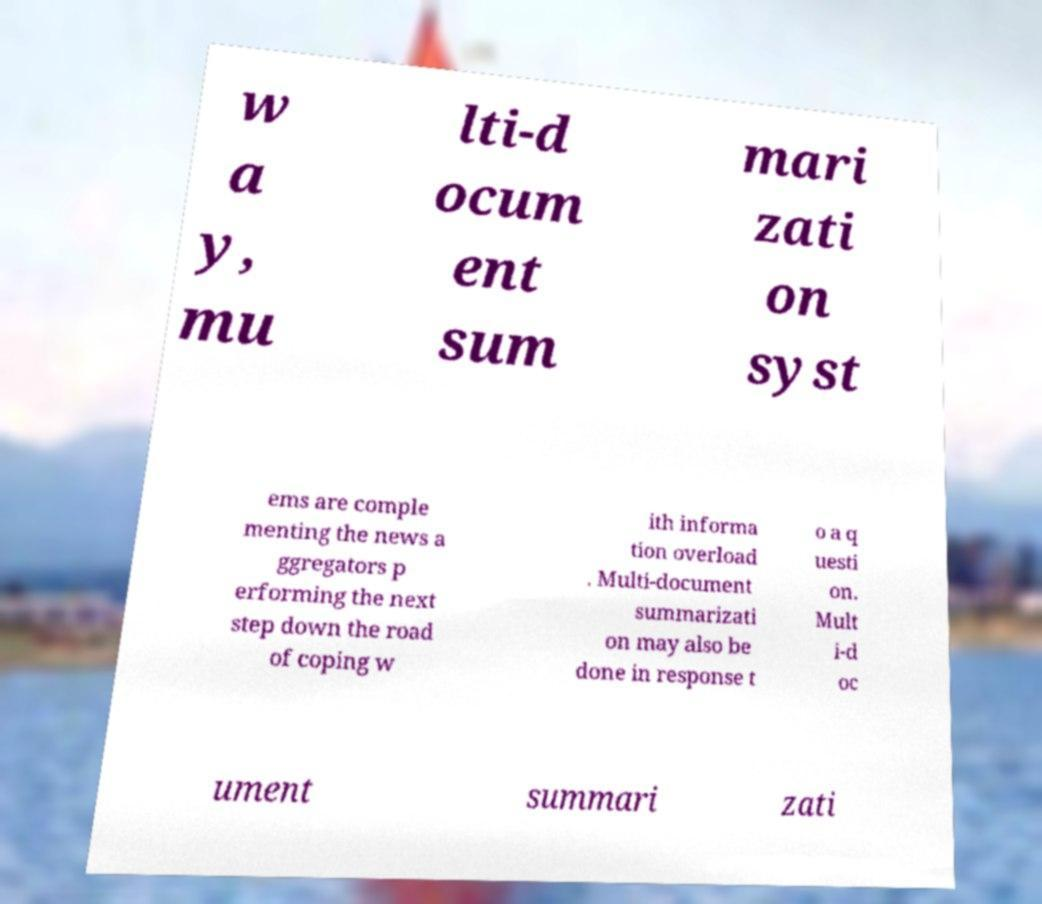Can you accurately transcribe the text from the provided image for me? w a y, mu lti-d ocum ent sum mari zati on syst ems are comple menting the news a ggregators p erforming the next step down the road of coping w ith informa tion overload . Multi-document summarizati on may also be done in response t o a q uesti on. Mult i-d oc ument summari zati 